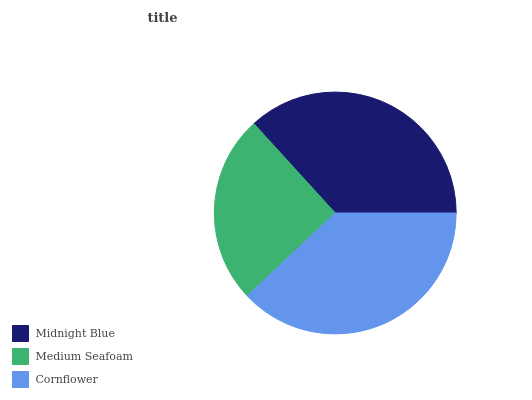Is Medium Seafoam the minimum?
Answer yes or no. Yes. Is Cornflower the maximum?
Answer yes or no. Yes. Is Cornflower the minimum?
Answer yes or no. No. Is Medium Seafoam the maximum?
Answer yes or no. No. Is Cornflower greater than Medium Seafoam?
Answer yes or no. Yes. Is Medium Seafoam less than Cornflower?
Answer yes or no. Yes. Is Medium Seafoam greater than Cornflower?
Answer yes or no. No. Is Cornflower less than Medium Seafoam?
Answer yes or no. No. Is Midnight Blue the high median?
Answer yes or no. Yes. Is Midnight Blue the low median?
Answer yes or no. Yes. Is Medium Seafoam the high median?
Answer yes or no. No. Is Cornflower the low median?
Answer yes or no. No. 